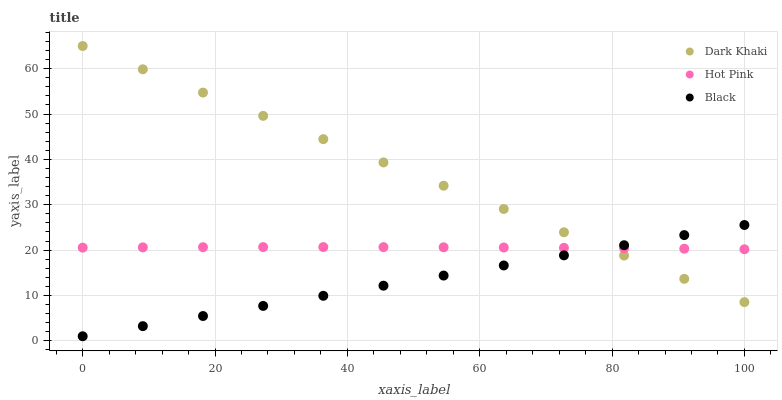Does Black have the minimum area under the curve?
Answer yes or no. Yes. Does Dark Khaki have the maximum area under the curve?
Answer yes or no. Yes. Does Hot Pink have the minimum area under the curve?
Answer yes or no. No. Does Hot Pink have the maximum area under the curve?
Answer yes or no. No. Is Black the smoothest?
Answer yes or no. Yes. Is Hot Pink the roughest?
Answer yes or no. Yes. Is Hot Pink the smoothest?
Answer yes or no. No. Is Black the roughest?
Answer yes or no. No. Does Black have the lowest value?
Answer yes or no. Yes. Does Hot Pink have the lowest value?
Answer yes or no. No. Does Dark Khaki have the highest value?
Answer yes or no. Yes. Does Black have the highest value?
Answer yes or no. No. Does Hot Pink intersect Dark Khaki?
Answer yes or no. Yes. Is Hot Pink less than Dark Khaki?
Answer yes or no. No. Is Hot Pink greater than Dark Khaki?
Answer yes or no. No. 